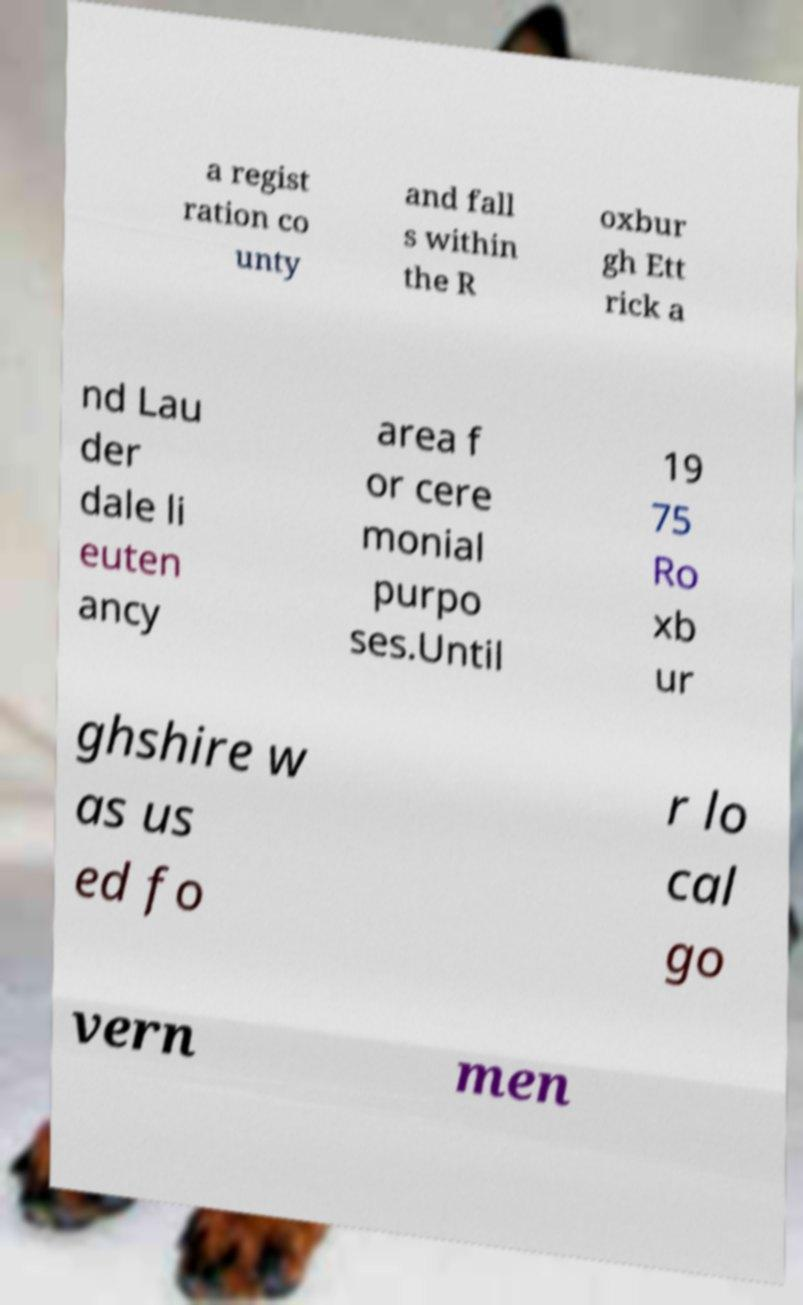Could you assist in decoding the text presented in this image and type it out clearly? a regist ration co unty and fall s within the R oxbur gh Ett rick a nd Lau der dale li euten ancy area f or cere monial purpo ses.Until 19 75 Ro xb ur ghshire w as us ed fo r lo cal go vern men 